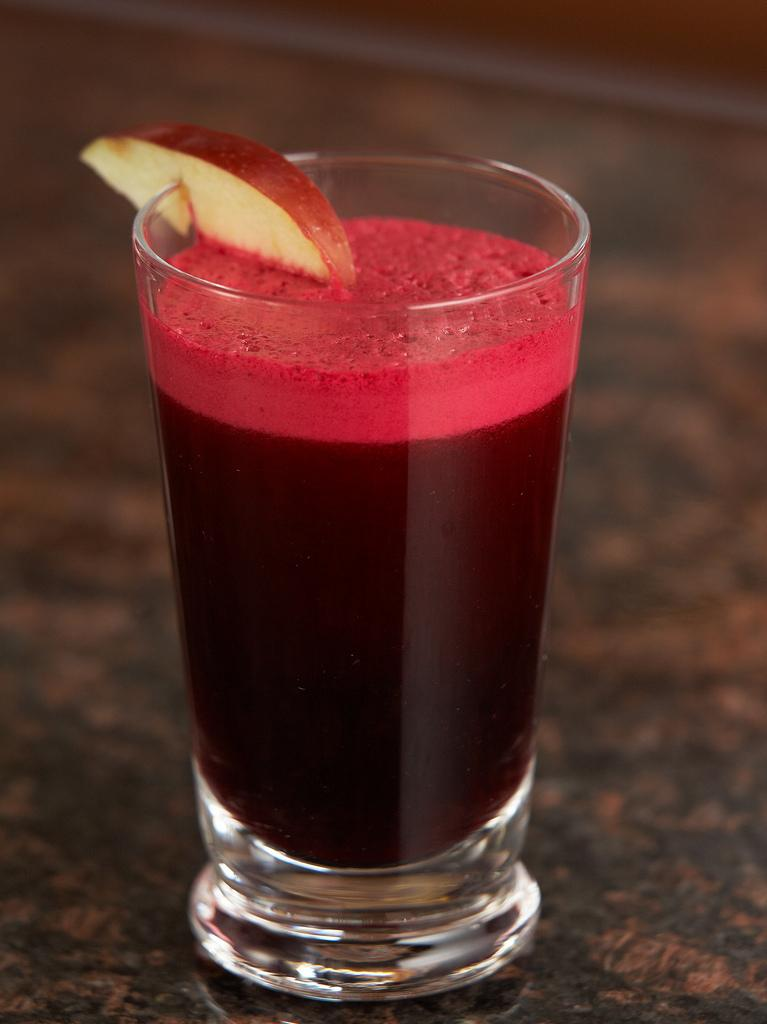What type of glass is visible in the image? There is a juice glass in the image. What is inside the juice glass? The facts do not specify what is inside the juice glass. What other item is visible in the image? There is an apple piece in the image. Where are the juice glass and apple piece located? The juice glass and apple piece are on a surface in the foreground. What type of fiction is the apple piece reading in the image? There is no indication in the image that the apple piece is reading any fiction, as it is a piece of fruit and not capable of reading. 